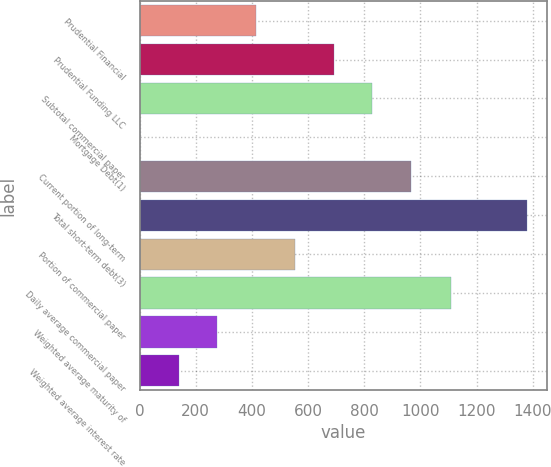Convert chart to OTSL. <chart><loc_0><loc_0><loc_500><loc_500><bar_chart><fcel>Prudential Financial<fcel>Prudential Funding LLC<fcel>Subtotal commercial paper<fcel>Mortgage Debt(1)<fcel>Current portion of long-term<fcel>Total short-term debt(3)<fcel>Portion of commercial paper<fcel>Daily average commercial paper<fcel>Weighted average maturity of<fcel>Weighted average interest rate<nl><fcel>414.64<fcel>690.46<fcel>828.37<fcel>0.91<fcel>966.28<fcel>1380<fcel>552.55<fcel>1110<fcel>276.73<fcel>138.82<nl></chart> 